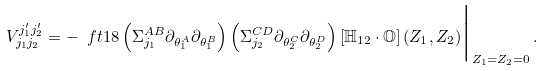<formula> <loc_0><loc_0><loc_500><loc_500>V _ { j _ { 1 } j _ { 2 } } ^ { j _ { 1 } ^ { \prime } j _ { 2 } ^ { \prime } } = - \ f t 1 8 \left ( \Sigma _ { j _ { 1 } } ^ { A B } \partial _ { \theta _ { 1 } ^ { A } } \partial _ { \theta _ { 1 } ^ { B } } \right ) \left ( \Sigma _ { j _ { 2 } } ^ { C D } \partial _ { \theta _ { 2 } ^ { C } } \partial _ { \theta _ { 2 } ^ { D } } \right ) \left [ \mathbb { H } _ { 1 2 } \cdot \mathbb { O } \right ] ( Z _ { 1 } , Z _ { 2 } ) \Big | _ { Z _ { 1 } = Z _ { 2 } = 0 } \, .</formula> 